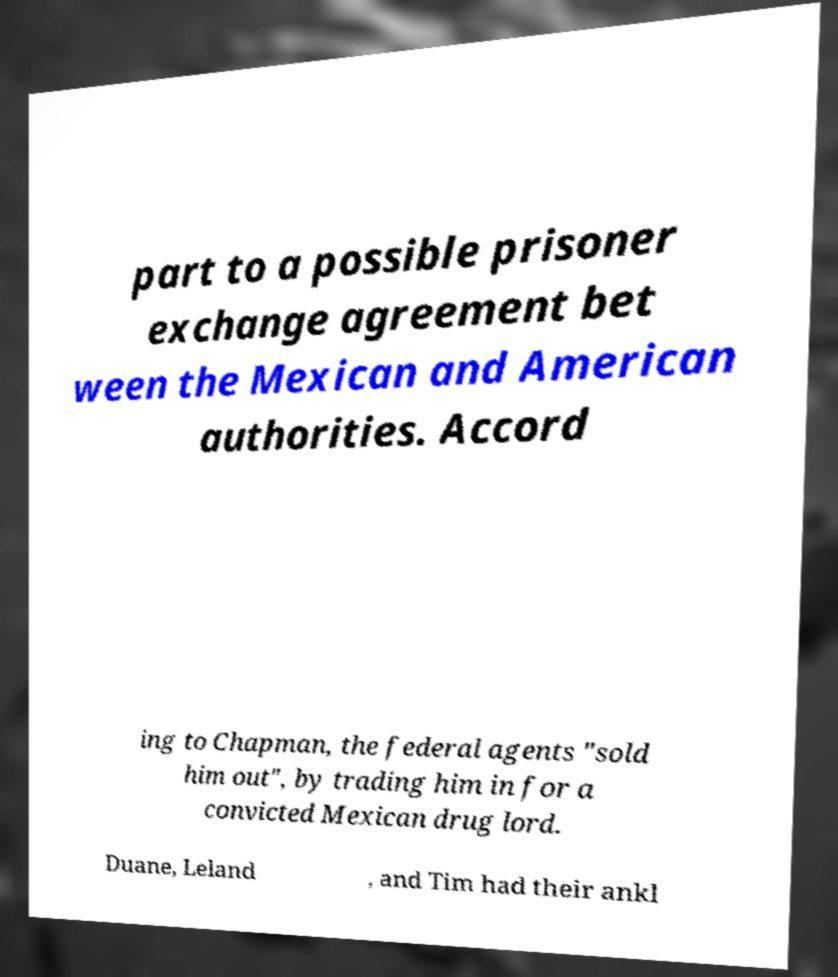Could you assist in decoding the text presented in this image and type it out clearly? part to a possible prisoner exchange agreement bet ween the Mexican and American authorities. Accord ing to Chapman, the federal agents "sold him out", by trading him in for a convicted Mexican drug lord. Duane, Leland , and Tim had their ankl 